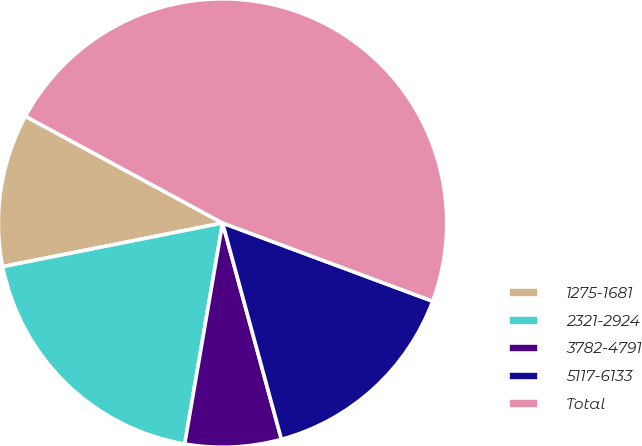Convert chart. <chart><loc_0><loc_0><loc_500><loc_500><pie_chart><fcel>1275-1681<fcel>2321-2924<fcel>3782-4791<fcel>5117-6133<fcel>Total<nl><fcel>11.02%<fcel>19.18%<fcel>6.93%<fcel>15.1%<fcel>47.77%<nl></chart> 